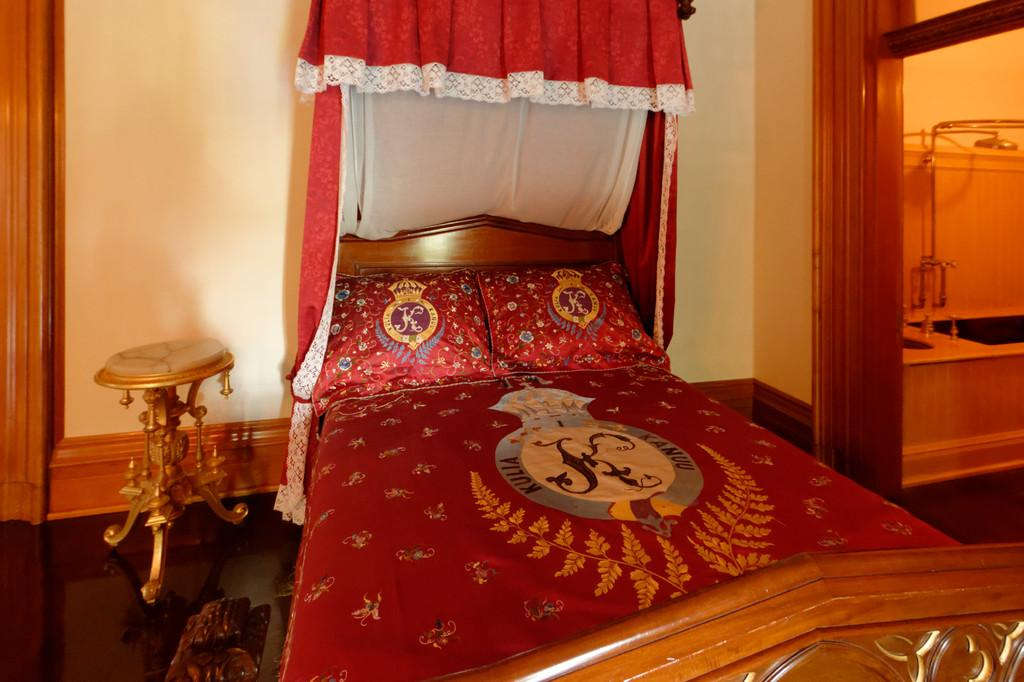What type of furniture is present in the image? There is a bed and a table in the image. What can be seen on the bed? There are pillows on the bed. What type of window treatment is visible in the image? There are curtains in the image. What type of structure is present in the image? There is a wall in the image. Where are the objects located in the image? The objects are on the right side of the image. What type of pocket can be seen in the image? There is no pocket present in the image. What type of shame is depicted in the image? There is no shame depicted in the image. 